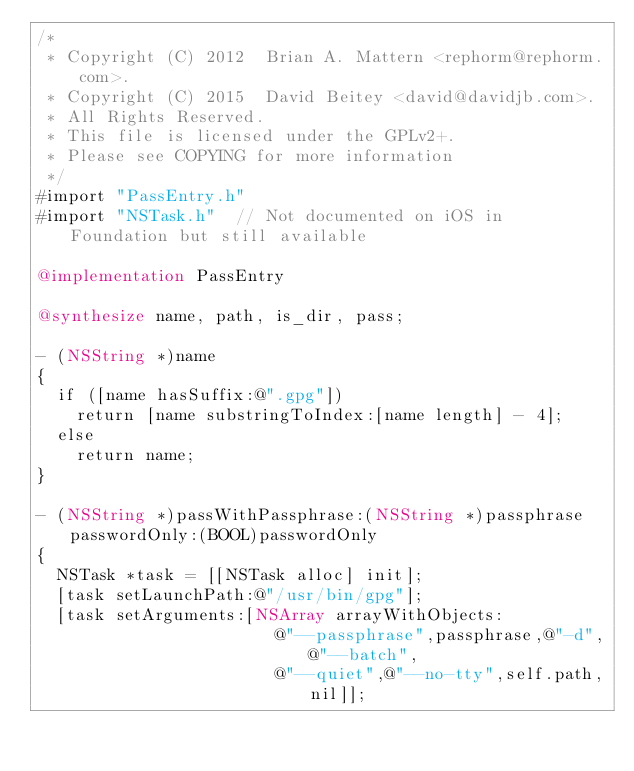<code> <loc_0><loc_0><loc_500><loc_500><_ObjectiveC_>/*
 * Copyright (C) 2012  Brian A. Mattern <rephorm@rephorm.com>.
 * Copyright (C) 2015  David Beitey <david@davidjb.com>.
 * All Rights Reserved.
 * This file is licensed under the GPLv2+.
 * Please see COPYING for more information
 */
#import "PassEntry.h"
#import "NSTask.h"  // Not documented on iOS in Foundation but still available

@implementation PassEntry

@synthesize name, path, is_dir, pass;

- (NSString *)name
{
  if ([name hasSuffix:@".gpg"])
    return [name substringToIndex:[name length] - 4];
  else
    return name;
}

- (NSString *)passWithPassphrase:(NSString *)passphrase passwordOnly:(BOOL)passwordOnly
{
  NSTask *task = [[NSTask alloc] init];
  [task setLaunchPath:@"/usr/bin/gpg"];
  [task setArguments:[NSArray arrayWithObjects:
                        @"--passphrase",passphrase,@"-d",@"--batch",
                        @"--quiet",@"--no-tty",self.path,nil]];
</code> 